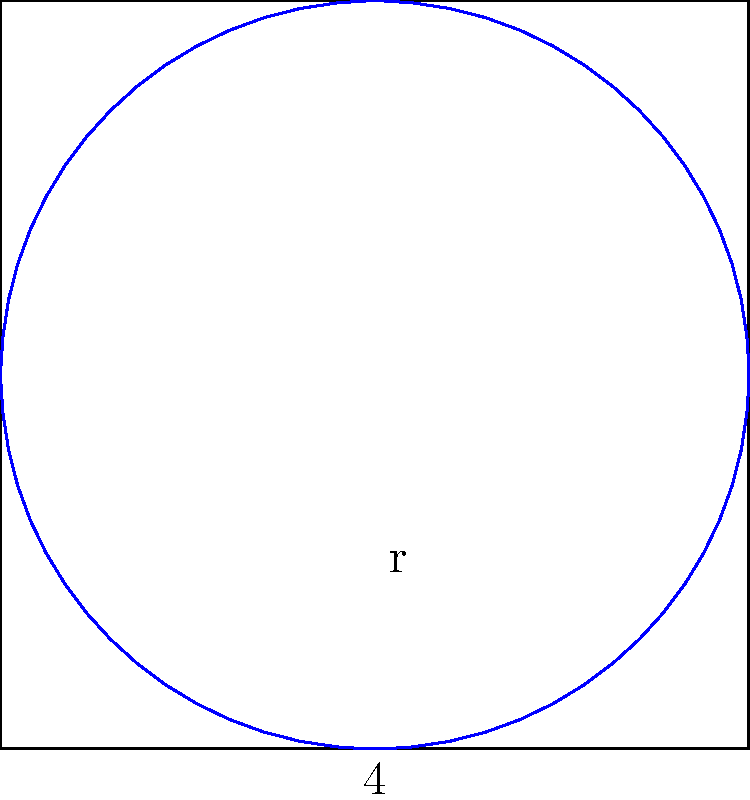In a magical kingdom, a young wizard is tasked with creating a circular protection spell within a square courtyard. The courtyard measures 4 units on each side, and the spell must touch all four sides of the courtyard. What is the area of the circular protection spell? Let's approach this step-by-step:

1) First, we need to identify that the circle is inscribed in the square, touching all four sides.

2) The diameter of the circle is equal to the side length of the square, which is 4 units.

3) Therefore, the radius of the circle is half of this, or 2 units.

4) The formula for the area of a circle is $A = \pi r^2$, where $r$ is the radius.

5) Substituting our radius:
   $A = \pi (2)^2$
   $A = \pi (4)$
   $A = 4\pi$

6) Therefore, the area of the circular protection spell is $4\pi$ square units.

This problem combines geometry with a fantasy setting, making it both educational and engaging for young readers who enjoy magical themes.
Answer: $4\pi$ square units 